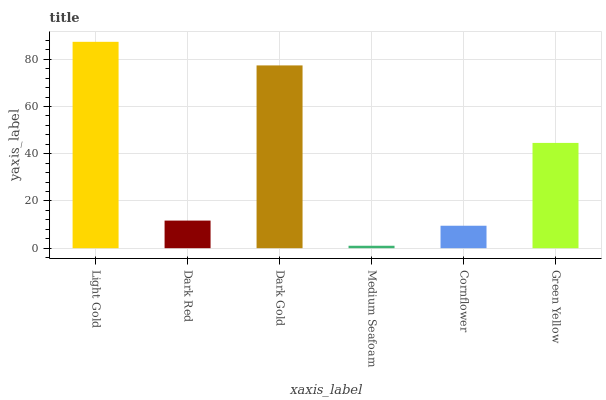Is Dark Red the minimum?
Answer yes or no. No. Is Dark Red the maximum?
Answer yes or no. No. Is Light Gold greater than Dark Red?
Answer yes or no. Yes. Is Dark Red less than Light Gold?
Answer yes or no. Yes. Is Dark Red greater than Light Gold?
Answer yes or no. No. Is Light Gold less than Dark Red?
Answer yes or no. No. Is Green Yellow the high median?
Answer yes or no. Yes. Is Dark Red the low median?
Answer yes or no. Yes. Is Dark Red the high median?
Answer yes or no. No. Is Dark Gold the low median?
Answer yes or no. No. 